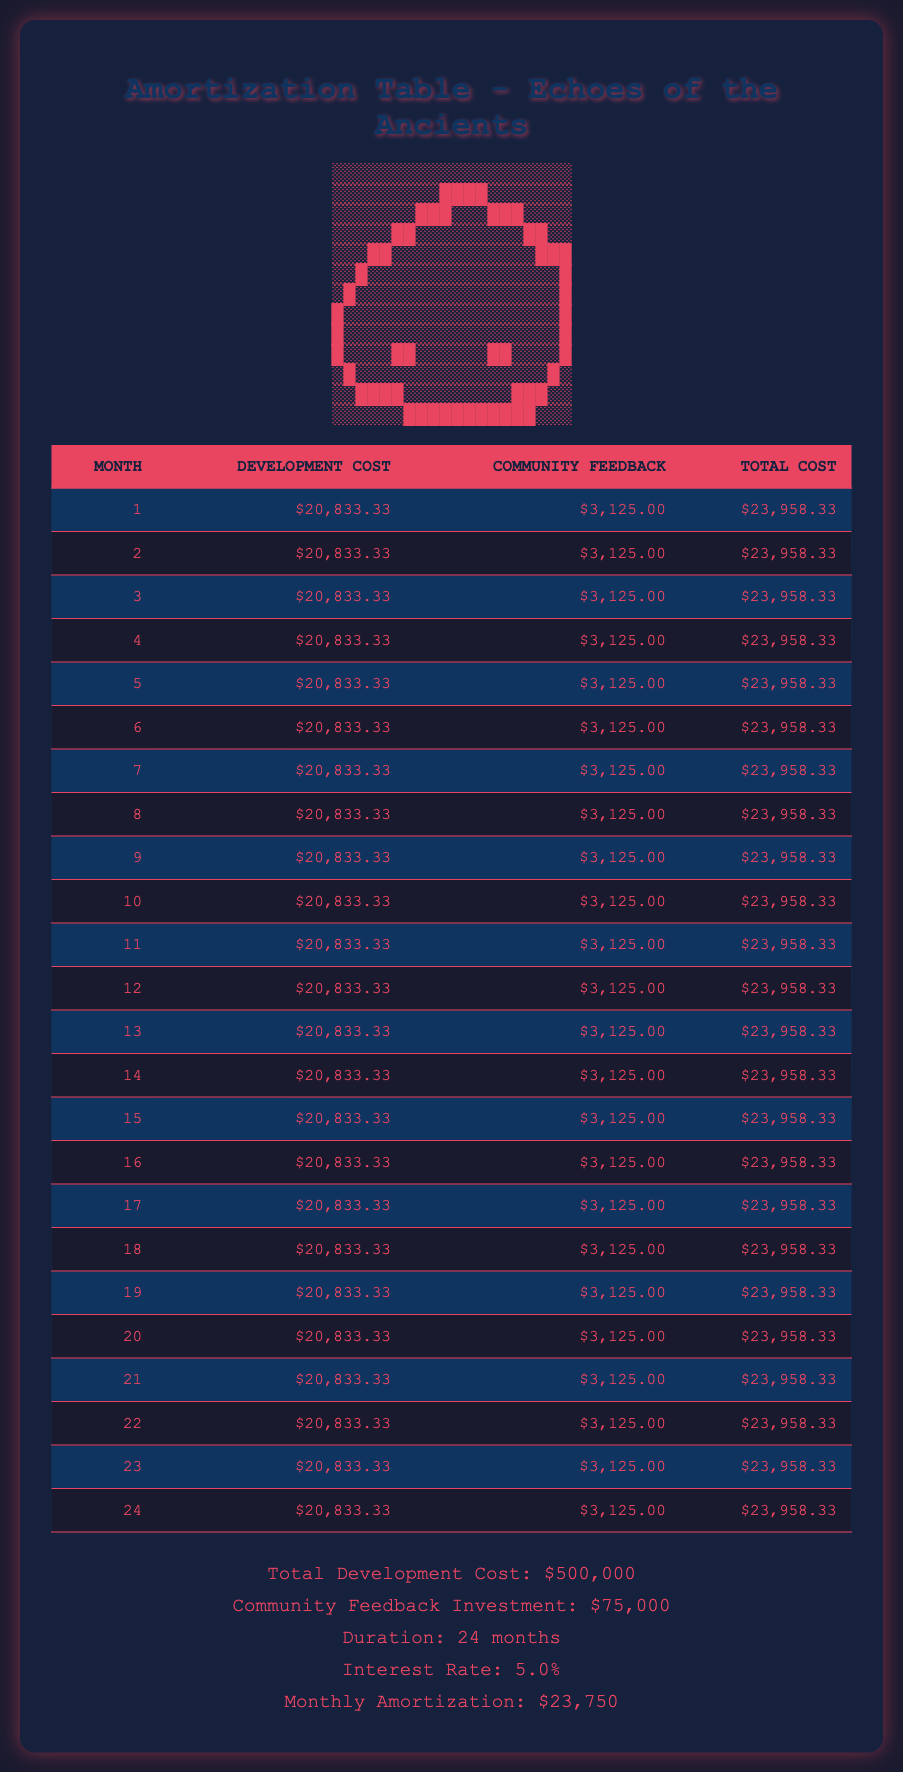What is the total development cost for the game? According to the summary at the bottom of the table, the total development cost for "Echoes of the Ancients" is provided directly as $500,000.
Answer: $500,000 What is the monthly cost for community feedback? Each month, the community feedback cost is listed as $3,125. This value is consistent across all months in the table.
Answer: $3,125 How much is the total cost in the 10th month? In the 10th month, the total cost for development and community feedback is $23,958.33, which is the sum of development cost ($20,833.33) and community feedback ($3,125).
Answer: $23,958.33 What is the average monthly development cost? The development cost is the same for all months at $20,833.33. Since there are 24 months, the average monthly development cost is simply $20,833.33.
Answer: $20,833.33 Is the community feedback investment higher than $50,000? The community feedback investment totals $75,000, which is indeed higher than $50,000.
Answer: Yes What is the total amount allocated to community feedback over the 24 months? The monthly community feedback cost is $3,125. Over 24 months, the total expenditure on community feedback is 24 * $3,125 = $75,000.
Answer: $75,000 How much does the game cost in the 15th month? The 15th month's total cost is again $23,958.33. This value is consistent with the total cost for other months, comprising development and community feedback costs.
Answer: $23,958.33 What is the difference between the total development cost and total community feedback investment? The total development cost is $500,000 and the total community feedback investment is $75,000. The difference is $500,000 - $75,000 = $425,000.
Answer: $425,000 Will the total cost for each month always remain the same? Yes, based on the provided amortization table data, the totals for each month are consistently $23,958.33, indicating stable monthly costs.
Answer: Yes 